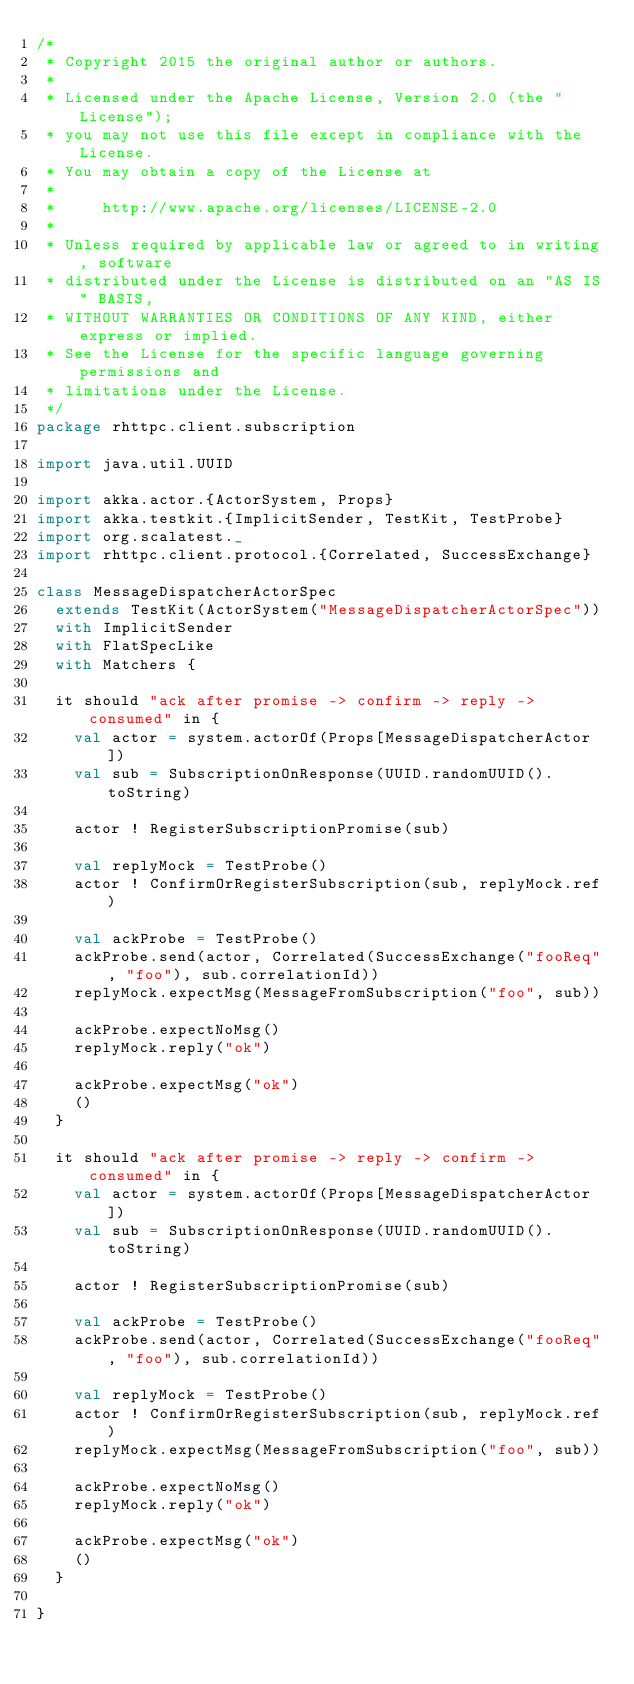Convert code to text. <code><loc_0><loc_0><loc_500><loc_500><_Scala_>/*
 * Copyright 2015 the original author or authors.
 *
 * Licensed under the Apache License, Version 2.0 (the "License");
 * you may not use this file except in compliance with the License.
 * You may obtain a copy of the License at
 *
 *     http://www.apache.org/licenses/LICENSE-2.0
 *
 * Unless required by applicable law or agreed to in writing, software
 * distributed under the License is distributed on an "AS IS" BASIS,
 * WITHOUT WARRANTIES OR CONDITIONS OF ANY KIND, either express or implied.
 * See the License for the specific language governing permissions and
 * limitations under the License.
 */
package rhttpc.client.subscription

import java.util.UUID

import akka.actor.{ActorSystem, Props}
import akka.testkit.{ImplicitSender, TestKit, TestProbe}
import org.scalatest._
import rhttpc.client.protocol.{Correlated, SuccessExchange}

class MessageDispatcherActorSpec
  extends TestKit(ActorSystem("MessageDispatcherActorSpec"))
  with ImplicitSender
  with FlatSpecLike
  with Matchers {

  it should "ack after promise -> confirm -> reply -> consumed" in {
    val actor = system.actorOf(Props[MessageDispatcherActor])
    val sub = SubscriptionOnResponse(UUID.randomUUID().toString)

    actor ! RegisterSubscriptionPromise(sub)

    val replyMock = TestProbe()
    actor ! ConfirmOrRegisterSubscription(sub, replyMock.ref)

    val ackProbe = TestProbe()
    ackProbe.send(actor, Correlated(SuccessExchange("fooReq", "foo"), sub.correlationId))
    replyMock.expectMsg(MessageFromSubscription("foo", sub))

    ackProbe.expectNoMsg()
    replyMock.reply("ok")

    ackProbe.expectMsg("ok")
    ()
  }

  it should "ack after promise -> reply -> confirm -> consumed" in {
    val actor = system.actorOf(Props[MessageDispatcherActor])
    val sub = SubscriptionOnResponse(UUID.randomUUID().toString)

    actor ! RegisterSubscriptionPromise(sub)

    val ackProbe = TestProbe()
    ackProbe.send(actor, Correlated(SuccessExchange("fooReq", "foo"), sub.correlationId))

    val replyMock = TestProbe()
    actor ! ConfirmOrRegisterSubscription(sub, replyMock.ref)
    replyMock.expectMsg(MessageFromSubscription("foo", sub))

    ackProbe.expectNoMsg()
    replyMock.reply("ok")

    ackProbe.expectMsg("ok")
    ()
  }

}</code> 